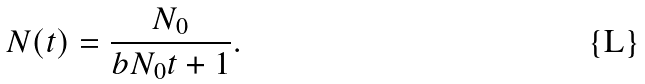Convert formula to latex. <formula><loc_0><loc_0><loc_500><loc_500>N ( t ) = \frac { N _ { 0 } } { b N _ { 0 } t + 1 } .</formula> 